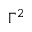Convert formula to latex. <formula><loc_0><loc_0><loc_500><loc_500>\Gamma ^ { 2 }</formula> 